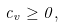Convert formula to latex. <formula><loc_0><loc_0><loc_500><loc_500>c _ { v } \geq 0 ,</formula> 